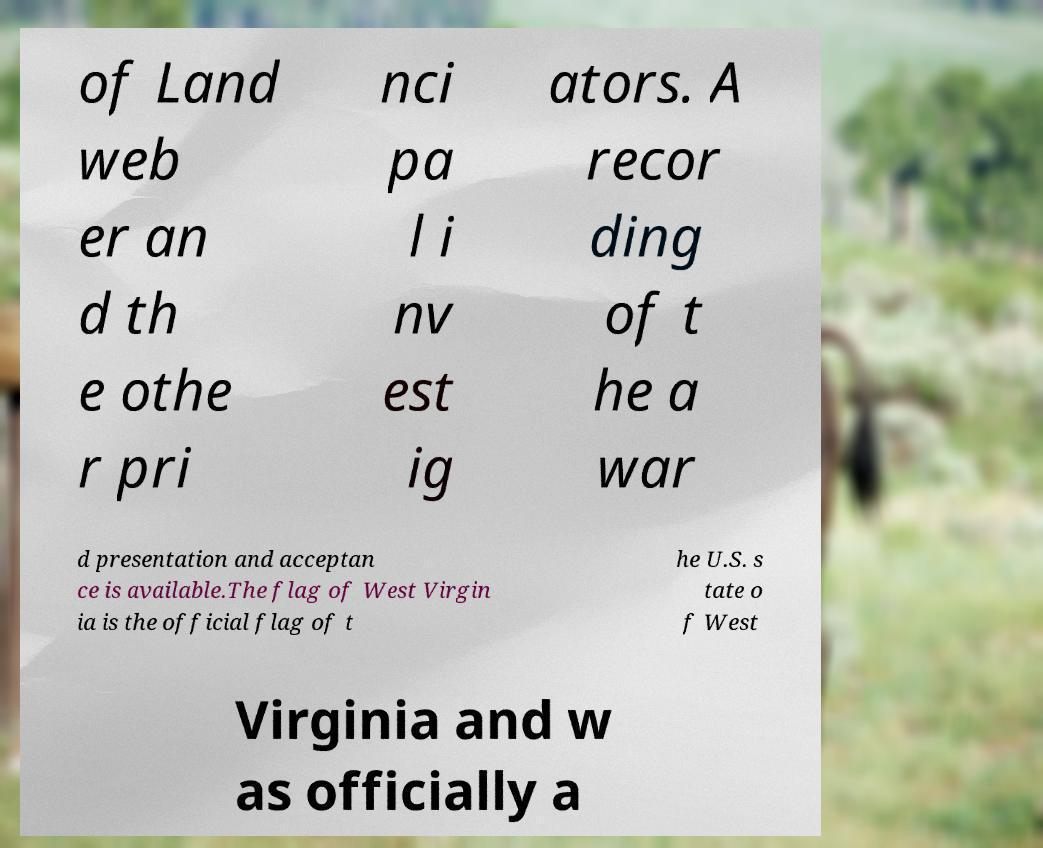Can you accurately transcribe the text from the provided image for me? of Land web er an d th e othe r pri nci pa l i nv est ig ators. A recor ding of t he a war d presentation and acceptan ce is available.The flag of West Virgin ia is the official flag of t he U.S. s tate o f West Virginia and w as officially a 